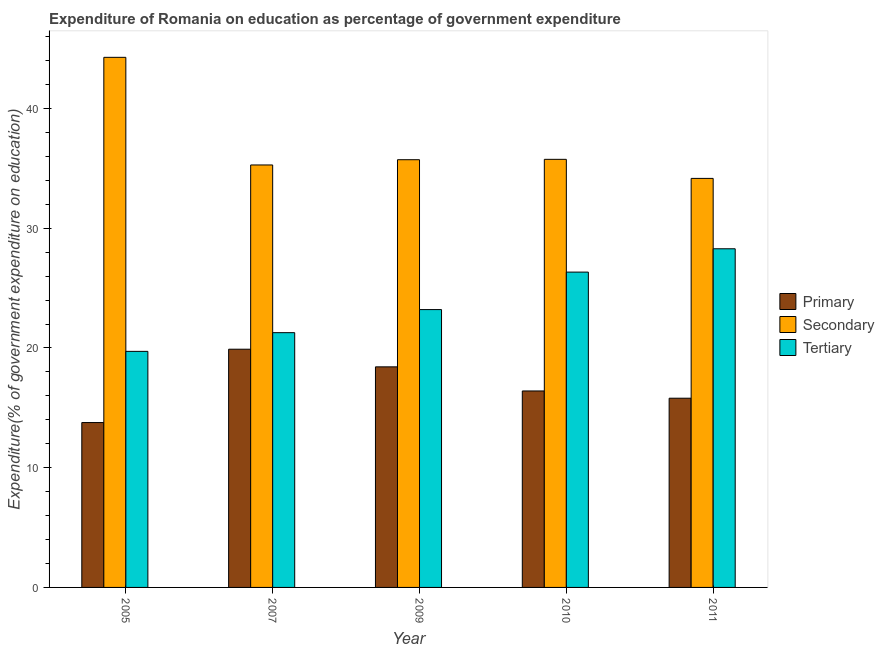How many bars are there on the 2nd tick from the left?
Offer a terse response. 3. What is the label of the 2nd group of bars from the left?
Offer a terse response. 2007. In how many cases, is the number of bars for a given year not equal to the number of legend labels?
Ensure brevity in your answer.  0. What is the expenditure on tertiary education in 2005?
Provide a short and direct response. 19.71. Across all years, what is the maximum expenditure on secondary education?
Ensure brevity in your answer.  44.27. Across all years, what is the minimum expenditure on secondary education?
Offer a very short reply. 34.16. What is the total expenditure on primary education in the graph?
Offer a terse response. 84.3. What is the difference between the expenditure on secondary education in 2007 and that in 2010?
Keep it short and to the point. -0.47. What is the difference between the expenditure on primary education in 2010 and the expenditure on secondary education in 2009?
Offer a very short reply. -2.01. What is the average expenditure on primary education per year?
Offer a very short reply. 16.86. What is the ratio of the expenditure on tertiary education in 2007 to that in 2011?
Offer a terse response. 0.75. Is the expenditure on tertiary education in 2009 less than that in 2011?
Provide a short and direct response. Yes. Is the difference between the expenditure on tertiary education in 2007 and 2011 greater than the difference between the expenditure on secondary education in 2007 and 2011?
Your answer should be compact. No. What is the difference between the highest and the second highest expenditure on tertiary education?
Ensure brevity in your answer.  1.95. What is the difference between the highest and the lowest expenditure on primary education?
Your answer should be compact. 6.12. What does the 2nd bar from the left in 2011 represents?
Provide a succinct answer. Secondary. What does the 2nd bar from the right in 2010 represents?
Offer a very short reply. Secondary. How many bars are there?
Your response must be concise. 15. How many years are there in the graph?
Your answer should be compact. 5. Where does the legend appear in the graph?
Your response must be concise. Center right. How many legend labels are there?
Keep it short and to the point. 3. What is the title of the graph?
Ensure brevity in your answer.  Expenditure of Romania on education as percentage of government expenditure. Does "Refusal of sex" appear as one of the legend labels in the graph?
Make the answer very short. No. What is the label or title of the Y-axis?
Ensure brevity in your answer.  Expenditure(% of government expenditure on education). What is the Expenditure(% of government expenditure on education) of Primary in 2005?
Make the answer very short. 13.77. What is the Expenditure(% of government expenditure on education) of Secondary in 2005?
Your answer should be very brief. 44.27. What is the Expenditure(% of government expenditure on education) of Tertiary in 2005?
Offer a very short reply. 19.71. What is the Expenditure(% of government expenditure on education) of Primary in 2007?
Your answer should be very brief. 19.89. What is the Expenditure(% of government expenditure on education) of Secondary in 2007?
Provide a short and direct response. 35.28. What is the Expenditure(% of government expenditure on education) of Tertiary in 2007?
Your response must be concise. 21.28. What is the Expenditure(% of government expenditure on education) in Primary in 2009?
Your answer should be compact. 18.42. What is the Expenditure(% of government expenditure on education) in Secondary in 2009?
Ensure brevity in your answer.  35.72. What is the Expenditure(% of government expenditure on education) of Tertiary in 2009?
Keep it short and to the point. 23.2. What is the Expenditure(% of government expenditure on education) in Primary in 2010?
Your response must be concise. 16.41. What is the Expenditure(% of government expenditure on education) in Secondary in 2010?
Give a very brief answer. 35.75. What is the Expenditure(% of government expenditure on education) of Tertiary in 2010?
Your answer should be very brief. 26.33. What is the Expenditure(% of government expenditure on education) in Primary in 2011?
Make the answer very short. 15.8. What is the Expenditure(% of government expenditure on education) in Secondary in 2011?
Give a very brief answer. 34.16. What is the Expenditure(% of government expenditure on education) in Tertiary in 2011?
Provide a short and direct response. 28.28. Across all years, what is the maximum Expenditure(% of government expenditure on education) in Primary?
Offer a very short reply. 19.89. Across all years, what is the maximum Expenditure(% of government expenditure on education) in Secondary?
Offer a terse response. 44.27. Across all years, what is the maximum Expenditure(% of government expenditure on education) in Tertiary?
Keep it short and to the point. 28.28. Across all years, what is the minimum Expenditure(% of government expenditure on education) in Primary?
Offer a terse response. 13.77. Across all years, what is the minimum Expenditure(% of government expenditure on education) in Secondary?
Provide a short and direct response. 34.16. Across all years, what is the minimum Expenditure(% of government expenditure on education) of Tertiary?
Give a very brief answer. 19.71. What is the total Expenditure(% of government expenditure on education) of Primary in the graph?
Ensure brevity in your answer.  84.3. What is the total Expenditure(% of government expenditure on education) of Secondary in the graph?
Provide a succinct answer. 185.18. What is the total Expenditure(% of government expenditure on education) of Tertiary in the graph?
Ensure brevity in your answer.  118.81. What is the difference between the Expenditure(% of government expenditure on education) in Primary in 2005 and that in 2007?
Offer a terse response. -6.12. What is the difference between the Expenditure(% of government expenditure on education) of Secondary in 2005 and that in 2007?
Offer a terse response. 8.99. What is the difference between the Expenditure(% of government expenditure on education) in Tertiary in 2005 and that in 2007?
Your answer should be very brief. -1.56. What is the difference between the Expenditure(% of government expenditure on education) in Primary in 2005 and that in 2009?
Your answer should be compact. -4.65. What is the difference between the Expenditure(% of government expenditure on education) in Secondary in 2005 and that in 2009?
Your answer should be very brief. 8.55. What is the difference between the Expenditure(% of government expenditure on education) in Tertiary in 2005 and that in 2009?
Ensure brevity in your answer.  -3.49. What is the difference between the Expenditure(% of government expenditure on education) in Primary in 2005 and that in 2010?
Your answer should be very brief. -2.64. What is the difference between the Expenditure(% of government expenditure on education) in Secondary in 2005 and that in 2010?
Keep it short and to the point. 8.52. What is the difference between the Expenditure(% of government expenditure on education) in Tertiary in 2005 and that in 2010?
Your response must be concise. -6.62. What is the difference between the Expenditure(% of government expenditure on education) in Primary in 2005 and that in 2011?
Offer a terse response. -2.03. What is the difference between the Expenditure(% of government expenditure on education) in Secondary in 2005 and that in 2011?
Offer a very short reply. 10.11. What is the difference between the Expenditure(% of government expenditure on education) of Tertiary in 2005 and that in 2011?
Your answer should be compact. -8.57. What is the difference between the Expenditure(% of government expenditure on education) of Primary in 2007 and that in 2009?
Your response must be concise. 1.47. What is the difference between the Expenditure(% of government expenditure on education) in Secondary in 2007 and that in 2009?
Your response must be concise. -0.44. What is the difference between the Expenditure(% of government expenditure on education) of Tertiary in 2007 and that in 2009?
Provide a succinct answer. -1.93. What is the difference between the Expenditure(% of government expenditure on education) in Primary in 2007 and that in 2010?
Your answer should be compact. 3.49. What is the difference between the Expenditure(% of government expenditure on education) of Secondary in 2007 and that in 2010?
Your response must be concise. -0.47. What is the difference between the Expenditure(% of government expenditure on education) in Tertiary in 2007 and that in 2010?
Provide a short and direct response. -5.06. What is the difference between the Expenditure(% of government expenditure on education) in Primary in 2007 and that in 2011?
Offer a terse response. 4.09. What is the difference between the Expenditure(% of government expenditure on education) in Secondary in 2007 and that in 2011?
Ensure brevity in your answer.  1.12. What is the difference between the Expenditure(% of government expenditure on education) of Tertiary in 2007 and that in 2011?
Make the answer very short. -7.01. What is the difference between the Expenditure(% of government expenditure on education) of Primary in 2009 and that in 2010?
Ensure brevity in your answer.  2.01. What is the difference between the Expenditure(% of government expenditure on education) in Secondary in 2009 and that in 2010?
Make the answer very short. -0.03. What is the difference between the Expenditure(% of government expenditure on education) of Tertiary in 2009 and that in 2010?
Your answer should be very brief. -3.13. What is the difference between the Expenditure(% of government expenditure on education) in Primary in 2009 and that in 2011?
Keep it short and to the point. 2.62. What is the difference between the Expenditure(% of government expenditure on education) of Secondary in 2009 and that in 2011?
Your response must be concise. 1.56. What is the difference between the Expenditure(% of government expenditure on education) in Tertiary in 2009 and that in 2011?
Your response must be concise. -5.08. What is the difference between the Expenditure(% of government expenditure on education) in Primary in 2010 and that in 2011?
Offer a very short reply. 0.61. What is the difference between the Expenditure(% of government expenditure on education) in Secondary in 2010 and that in 2011?
Give a very brief answer. 1.59. What is the difference between the Expenditure(% of government expenditure on education) in Tertiary in 2010 and that in 2011?
Ensure brevity in your answer.  -1.95. What is the difference between the Expenditure(% of government expenditure on education) in Primary in 2005 and the Expenditure(% of government expenditure on education) in Secondary in 2007?
Your answer should be compact. -21.51. What is the difference between the Expenditure(% of government expenditure on education) in Primary in 2005 and the Expenditure(% of government expenditure on education) in Tertiary in 2007?
Make the answer very short. -7.51. What is the difference between the Expenditure(% of government expenditure on education) of Secondary in 2005 and the Expenditure(% of government expenditure on education) of Tertiary in 2007?
Offer a very short reply. 23. What is the difference between the Expenditure(% of government expenditure on education) in Primary in 2005 and the Expenditure(% of government expenditure on education) in Secondary in 2009?
Your response must be concise. -21.95. What is the difference between the Expenditure(% of government expenditure on education) in Primary in 2005 and the Expenditure(% of government expenditure on education) in Tertiary in 2009?
Keep it short and to the point. -9.43. What is the difference between the Expenditure(% of government expenditure on education) in Secondary in 2005 and the Expenditure(% of government expenditure on education) in Tertiary in 2009?
Offer a terse response. 21.07. What is the difference between the Expenditure(% of government expenditure on education) in Primary in 2005 and the Expenditure(% of government expenditure on education) in Secondary in 2010?
Provide a succinct answer. -21.98. What is the difference between the Expenditure(% of government expenditure on education) of Primary in 2005 and the Expenditure(% of government expenditure on education) of Tertiary in 2010?
Offer a terse response. -12.56. What is the difference between the Expenditure(% of government expenditure on education) of Secondary in 2005 and the Expenditure(% of government expenditure on education) of Tertiary in 2010?
Your answer should be very brief. 17.94. What is the difference between the Expenditure(% of government expenditure on education) in Primary in 2005 and the Expenditure(% of government expenditure on education) in Secondary in 2011?
Offer a terse response. -20.39. What is the difference between the Expenditure(% of government expenditure on education) of Primary in 2005 and the Expenditure(% of government expenditure on education) of Tertiary in 2011?
Give a very brief answer. -14.51. What is the difference between the Expenditure(% of government expenditure on education) of Secondary in 2005 and the Expenditure(% of government expenditure on education) of Tertiary in 2011?
Your answer should be compact. 15.99. What is the difference between the Expenditure(% of government expenditure on education) of Primary in 2007 and the Expenditure(% of government expenditure on education) of Secondary in 2009?
Give a very brief answer. -15.83. What is the difference between the Expenditure(% of government expenditure on education) of Primary in 2007 and the Expenditure(% of government expenditure on education) of Tertiary in 2009?
Offer a very short reply. -3.31. What is the difference between the Expenditure(% of government expenditure on education) of Secondary in 2007 and the Expenditure(% of government expenditure on education) of Tertiary in 2009?
Your response must be concise. 12.08. What is the difference between the Expenditure(% of government expenditure on education) of Primary in 2007 and the Expenditure(% of government expenditure on education) of Secondary in 2010?
Ensure brevity in your answer.  -15.86. What is the difference between the Expenditure(% of government expenditure on education) of Primary in 2007 and the Expenditure(% of government expenditure on education) of Tertiary in 2010?
Provide a succinct answer. -6.44. What is the difference between the Expenditure(% of government expenditure on education) of Secondary in 2007 and the Expenditure(% of government expenditure on education) of Tertiary in 2010?
Keep it short and to the point. 8.95. What is the difference between the Expenditure(% of government expenditure on education) in Primary in 2007 and the Expenditure(% of government expenditure on education) in Secondary in 2011?
Give a very brief answer. -14.27. What is the difference between the Expenditure(% of government expenditure on education) of Primary in 2007 and the Expenditure(% of government expenditure on education) of Tertiary in 2011?
Offer a terse response. -8.39. What is the difference between the Expenditure(% of government expenditure on education) of Secondary in 2007 and the Expenditure(% of government expenditure on education) of Tertiary in 2011?
Offer a very short reply. 7. What is the difference between the Expenditure(% of government expenditure on education) of Primary in 2009 and the Expenditure(% of government expenditure on education) of Secondary in 2010?
Your response must be concise. -17.33. What is the difference between the Expenditure(% of government expenditure on education) of Primary in 2009 and the Expenditure(% of government expenditure on education) of Tertiary in 2010?
Give a very brief answer. -7.91. What is the difference between the Expenditure(% of government expenditure on education) of Secondary in 2009 and the Expenditure(% of government expenditure on education) of Tertiary in 2010?
Provide a succinct answer. 9.39. What is the difference between the Expenditure(% of government expenditure on education) of Primary in 2009 and the Expenditure(% of government expenditure on education) of Secondary in 2011?
Keep it short and to the point. -15.74. What is the difference between the Expenditure(% of government expenditure on education) of Primary in 2009 and the Expenditure(% of government expenditure on education) of Tertiary in 2011?
Offer a terse response. -9.86. What is the difference between the Expenditure(% of government expenditure on education) in Secondary in 2009 and the Expenditure(% of government expenditure on education) in Tertiary in 2011?
Give a very brief answer. 7.44. What is the difference between the Expenditure(% of government expenditure on education) of Primary in 2010 and the Expenditure(% of government expenditure on education) of Secondary in 2011?
Your response must be concise. -17.75. What is the difference between the Expenditure(% of government expenditure on education) of Primary in 2010 and the Expenditure(% of government expenditure on education) of Tertiary in 2011?
Make the answer very short. -11.87. What is the difference between the Expenditure(% of government expenditure on education) of Secondary in 2010 and the Expenditure(% of government expenditure on education) of Tertiary in 2011?
Make the answer very short. 7.47. What is the average Expenditure(% of government expenditure on education) of Primary per year?
Ensure brevity in your answer.  16.86. What is the average Expenditure(% of government expenditure on education) of Secondary per year?
Your answer should be very brief. 37.04. What is the average Expenditure(% of government expenditure on education) in Tertiary per year?
Keep it short and to the point. 23.76. In the year 2005, what is the difference between the Expenditure(% of government expenditure on education) in Primary and Expenditure(% of government expenditure on education) in Secondary?
Provide a succinct answer. -30.5. In the year 2005, what is the difference between the Expenditure(% of government expenditure on education) of Primary and Expenditure(% of government expenditure on education) of Tertiary?
Provide a short and direct response. -5.95. In the year 2005, what is the difference between the Expenditure(% of government expenditure on education) in Secondary and Expenditure(% of government expenditure on education) in Tertiary?
Make the answer very short. 24.56. In the year 2007, what is the difference between the Expenditure(% of government expenditure on education) in Primary and Expenditure(% of government expenditure on education) in Secondary?
Your answer should be compact. -15.39. In the year 2007, what is the difference between the Expenditure(% of government expenditure on education) in Primary and Expenditure(% of government expenditure on education) in Tertiary?
Your answer should be very brief. -1.38. In the year 2007, what is the difference between the Expenditure(% of government expenditure on education) of Secondary and Expenditure(% of government expenditure on education) of Tertiary?
Provide a succinct answer. 14.01. In the year 2009, what is the difference between the Expenditure(% of government expenditure on education) of Primary and Expenditure(% of government expenditure on education) of Secondary?
Your answer should be very brief. -17.3. In the year 2009, what is the difference between the Expenditure(% of government expenditure on education) in Primary and Expenditure(% of government expenditure on education) in Tertiary?
Your answer should be very brief. -4.78. In the year 2009, what is the difference between the Expenditure(% of government expenditure on education) of Secondary and Expenditure(% of government expenditure on education) of Tertiary?
Offer a terse response. 12.52. In the year 2010, what is the difference between the Expenditure(% of government expenditure on education) in Primary and Expenditure(% of government expenditure on education) in Secondary?
Keep it short and to the point. -19.34. In the year 2010, what is the difference between the Expenditure(% of government expenditure on education) in Primary and Expenditure(% of government expenditure on education) in Tertiary?
Give a very brief answer. -9.93. In the year 2010, what is the difference between the Expenditure(% of government expenditure on education) of Secondary and Expenditure(% of government expenditure on education) of Tertiary?
Offer a very short reply. 9.42. In the year 2011, what is the difference between the Expenditure(% of government expenditure on education) in Primary and Expenditure(% of government expenditure on education) in Secondary?
Ensure brevity in your answer.  -18.36. In the year 2011, what is the difference between the Expenditure(% of government expenditure on education) of Primary and Expenditure(% of government expenditure on education) of Tertiary?
Provide a short and direct response. -12.48. In the year 2011, what is the difference between the Expenditure(% of government expenditure on education) of Secondary and Expenditure(% of government expenditure on education) of Tertiary?
Your response must be concise. 5.88. What is the ratio of the Expenditure(% of government expenditure on education) in Primary in 2005 to that in 2007?
Your answer should be very brief. 0.69. What is the ratio of the Expenditure(% of government expenditure on education) in Secondary in 2005 to that in 2007?
Your response must be concise. 1.25. What is the ratio of the Expenditure(% of government expenditure on education) of Tertiary in 2005 to that in 2007?
Offer a terse response. 0.93. What is the ratio of the Expenditure(% of government expenditure on education) in Primary in 2005 to that in 2009?
Give a very brief answer. 0.75. What is the ratio of the Expenditure(% of government expenditure on education) in Secondary in 2005 to that in 2009?
Make the answer very short. 1.24. What is the ratio of the Expenditure(% of government expenditure on education) in Tertiary in 2005 to that in 2009?
Your answer should be compact. 0.85. What is the ratio of the Expenditure(% of government expenditure on education) of Primary in 2005 to that in 2010?
Offer a terse response. 0.84. What is the ratio of the Expenditure(% of government expenditure on education) of Secondary in 2005 to that in 2010?
Ensure brevity in your answer.  1.24. What is the ratio of the Expenditure(% of government expenditure on education) of Tertiary in 2005 to that in 2010?
Provide a succinct answer. 0.75. What is the ratio of the Expenditure(% of government expenditure on education) of Primary in 2005 to that in 2011?
Provide a short and direct response. 0.87. What is the ratio of the Expenditure(% of government expenditure on education) in Secondary in 2005 to that in 2011?
Make the answer very short. 1.3. What is the ratio of the Expenditure(% of government expenditure on education) in Tertiary in 2005 to that in 2011?
Your answer should be compact. 0.7. What is the ratio of the Expenditure(% of government expenditure on education) of Primary in 2007 to that in 2009?
Provide a short and direct response. 1.08. What is the ratio of the Expenditure(% of government expenditure on education) in Secondary in 2007 to that in 2009?
Your answer should be very brief. 0.99. What is the ratio of the Expenditure(% of government expenditure on education) of Tertiary in 2007 to that in 2009?
Make the answer very short. 0.92. What is the ratio of the Expenditure(% of government expenditure on education) of Primary in 2007 to that in 2010?
Offer a very short reply. 1.21. What is the ratio of the Expenditure(% of government expenditure on education) of Secondary in 2007 to that in 2010?
Give a very brief answer. 0.99. What is the ratio of the Expenditure(% of government expenditure on education) in Tertiary in 2007 to that in 2010?
Give a very brief answer. 0.81. What is the ratio of the Expenditure(% of government expenditure on education) in Primary in 2007 to that in 2011?
Provide a short and direct response. 1.26. What is the ratio of the Expenditure(% of government expenditure on education) in Secondary in 2007 to that in 2011?
Give a very brief answer. 1.03. What is the ratio of the Expenditure(% of government expenditure on education) in Tertiary in 2007 to that in 2011?
Your response must be concise. 0.75. What is the ratio of the Expenditure(% of government expenditure on education) in Primary in 2009 to that in 2010?
Your response must be concise. 1.12. What is the ratio of the Expenditure(% of government expenditure on education) in Tertiary in 2009 to that in 2010?
Make the answer very short. 0.88. What is the ratio of the Expenditure(% of government expenditure on education) of Primary in 2009 to that in 2011?
Make the answer very short. 1.17. What is the ratio of the Expenditure(% of government expenditure on education) in Secondary in 2009 to that in 2011?
Keep it short and to the point. 1.05. What is the ratio of the Expenditure(% of government expenditure on education) of Tertiary in 2009 to that in 2011?
Your answer should be compact. 0.82. What is the ratio of the Expenditure(% of government expenditure on education) of Primary in 2010 to that in 2011?
Give a very brief answer. 1.04. What is the ratio of the Expenditure(% of government expenditure on education) in Secondary in 2010 to that in 2011?
Offer a very short reply. 1.05. What is the ratio of the Expenditure(% of government expenditure on education) of Tertiary in 2010 to that in 2011?
Keep it short and to the point. 0.93. What is the difference between the highest and the second highest Expenditure(% of government expenditure on education) of Primary?
Provide a succinct answer. 1.47. What is the difference between the highest and the second highest Expenditure(% of government expenditure on education) of Secondary?
Provide a short and direct response. 8.52. What is the difference between the highest and the second highest Expenditure(% of government expenditure on education) of Tertiary?
Offer a terse response. 1.95. What is the difference between the highest and the lowest Expenditure(% of government expenditure on education) of Primary?
Your answer should be very brief. 6.12. What is the difference between the highest and the lowest Expenditure(% of government expenditure on education) of Secondary?
Keep it short and to the point. 10.11. What is the difference between the highest and the lowest Expenditure(% of government expenditure on education) in Tertiary?
Keep it short and to the point. 8.57. 